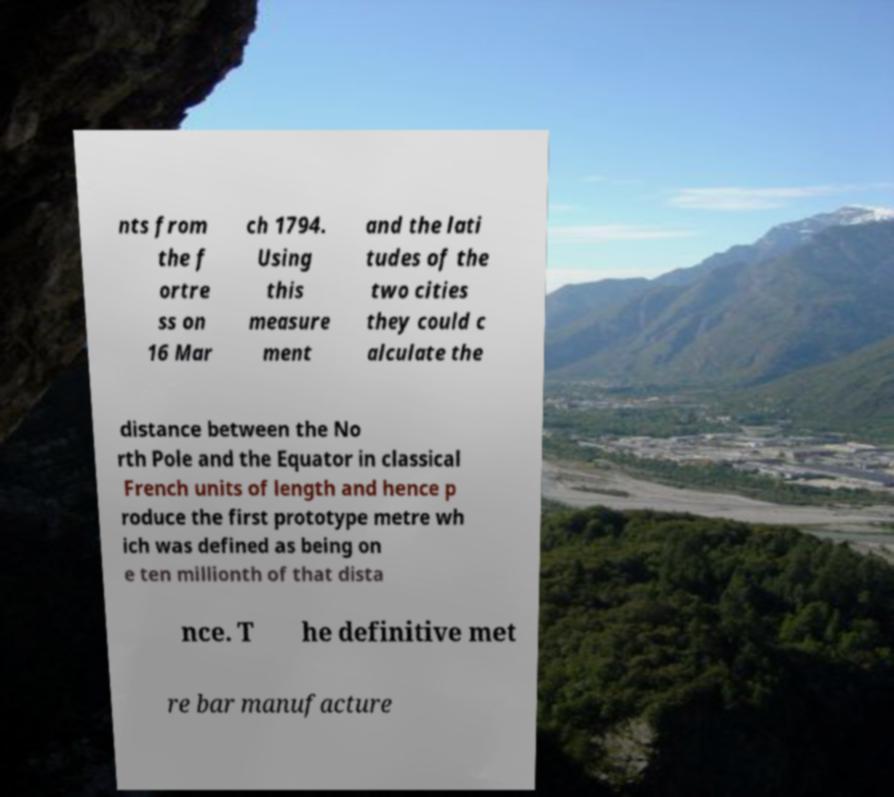Could you assist in decoding the text presented in this image and type it out clearly? nts from the f ortre ss on 16 Mar ch 1794. Using this measure ment and the lati tudes of the two cities they could c alculate the distance between the No rth Pole and the Equator in classical French units of length and hence p roduce the first prototype metre wh ich was defined as being on e ten millionth of that dista nce. T he definitive met re bar manufacture 